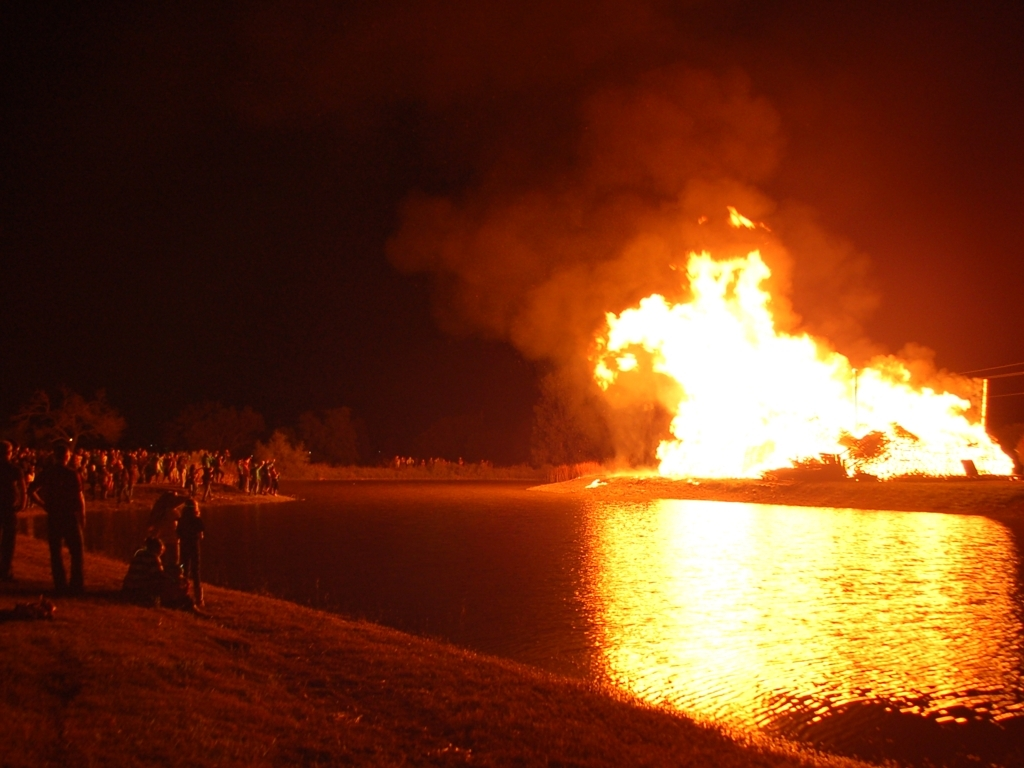How might the people in the image be feeling? While it's not possible to determine their exact emotions, the spectators might be feeling a mix of awe at the sheer size of the fire and enjoyment if it's a celebratory event. If it's an emergency, they could be feeling concern and anxiety. Their safe distance suggests they are spectating rather than panicking, implying planned activity. 